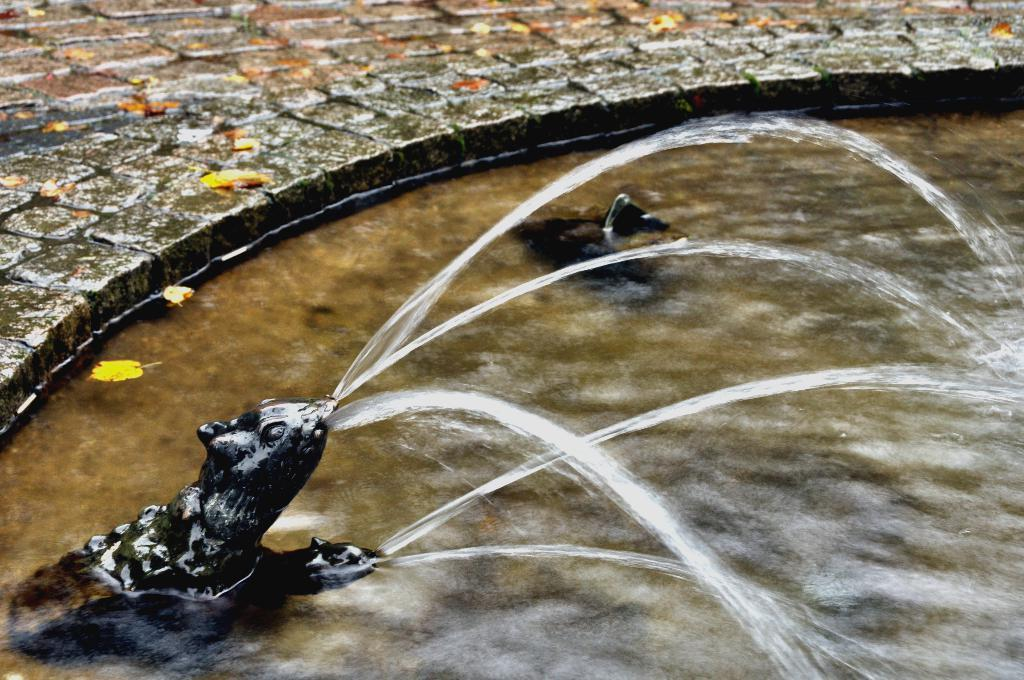What is the main feature in the image? There is a fountain in the image. What else can be seen near the fountain? There is a sculpture of an animal in the image. What is the state of the water in the image? There is water visible in the image. What type of vegetation is present on the ground in the image? There are leaves on the ground in the image. What type of turkey is being served at the table in the image? There is no table or turkey present in the image; it features a fountain and a sculpture of an animal. What mathematical operation is being performed on the bell in the image? There is no bell present in the image, so no mathematical operation can be performed on it. 